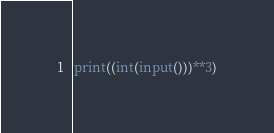<code> <loc_0><loc_0><loc_500><loc_500><_Python_>print((int(input()))**3)</code> 